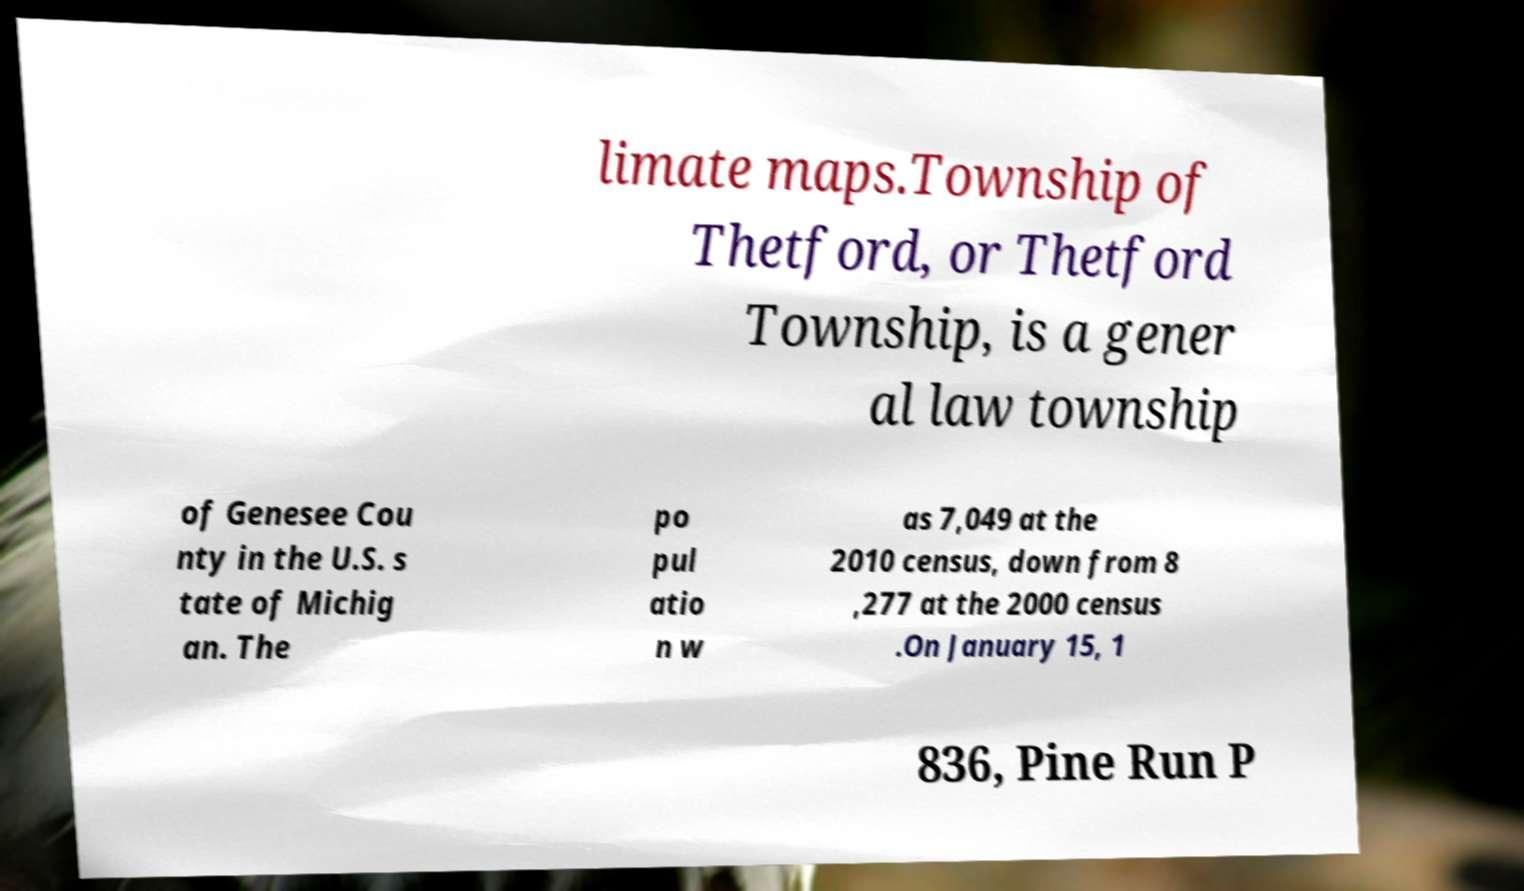Please identify and transcribe the text found in this image. limate maps.Township of Thetford, or Thetford Township, is a gener al law township of Genesee Cou nty in the U.S. s tate of Michig an. The po pul atio n w as 7,049 at the 2010 census, down from 8 ,277 at the 2000 census .On January 15, 1 836, Pine Run P 